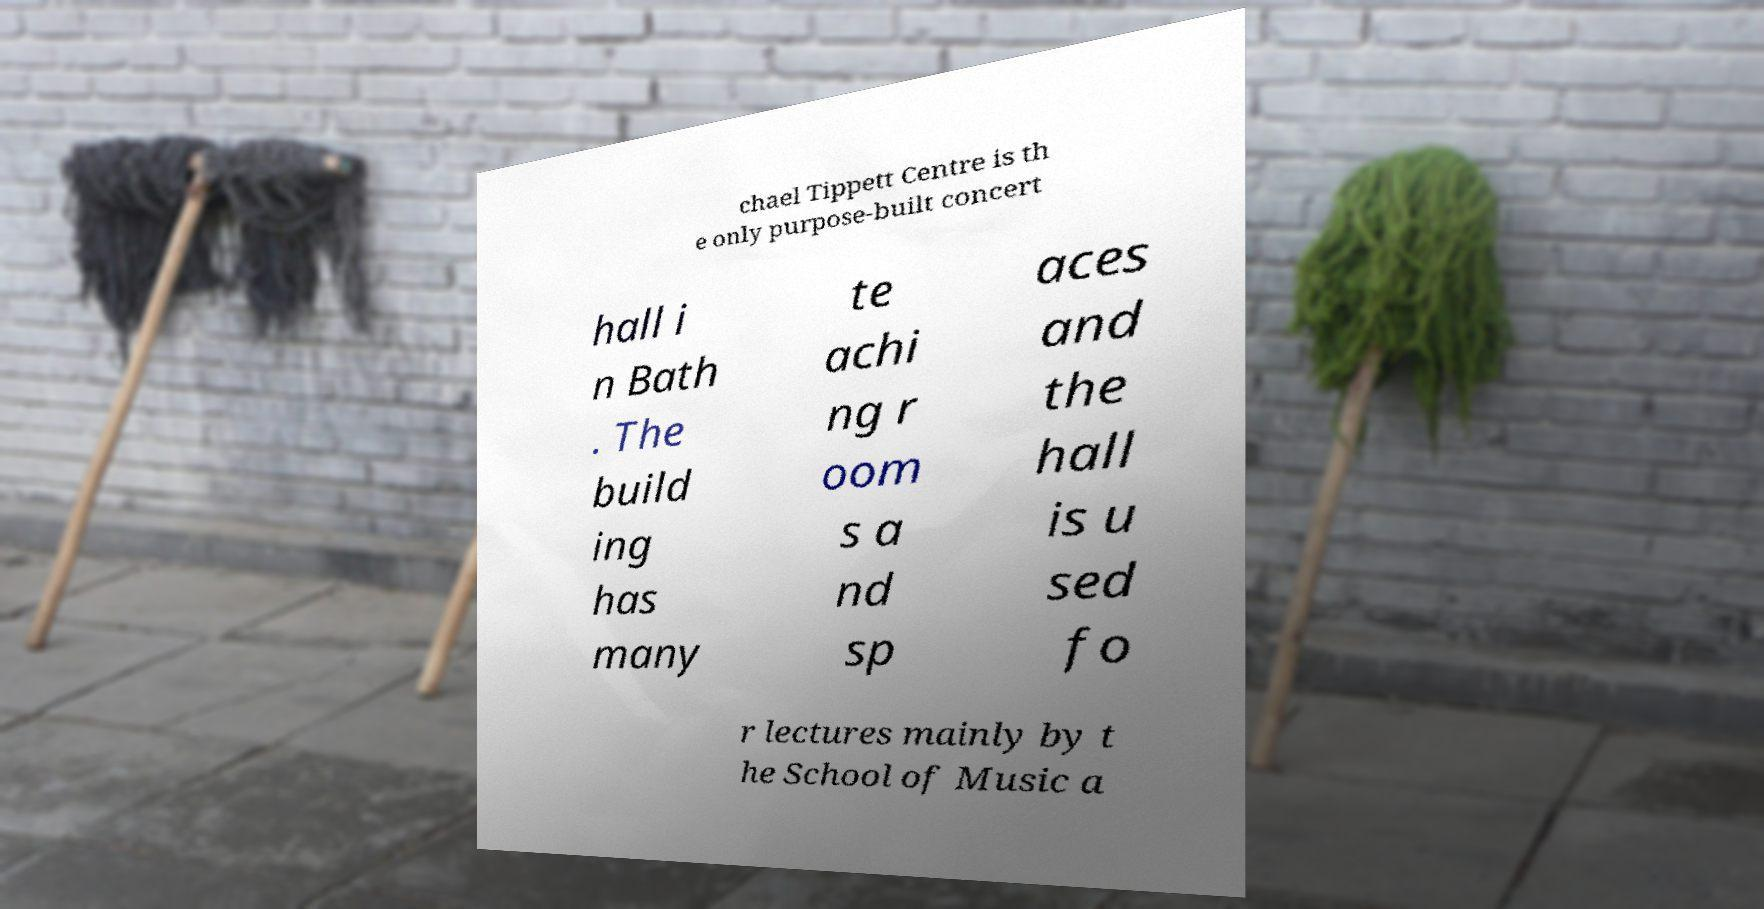Can you read and provide the text displayed in the image?This photo seems to have some interesting text. Can you extract and type it out for me? chael Tippett Centre is th e only purpose-built concert hall i n Bath . The build ing has many te achi ng r oom s a nd sp aces and the hall is u sed fo r lectures mainly by t he School of Music a 